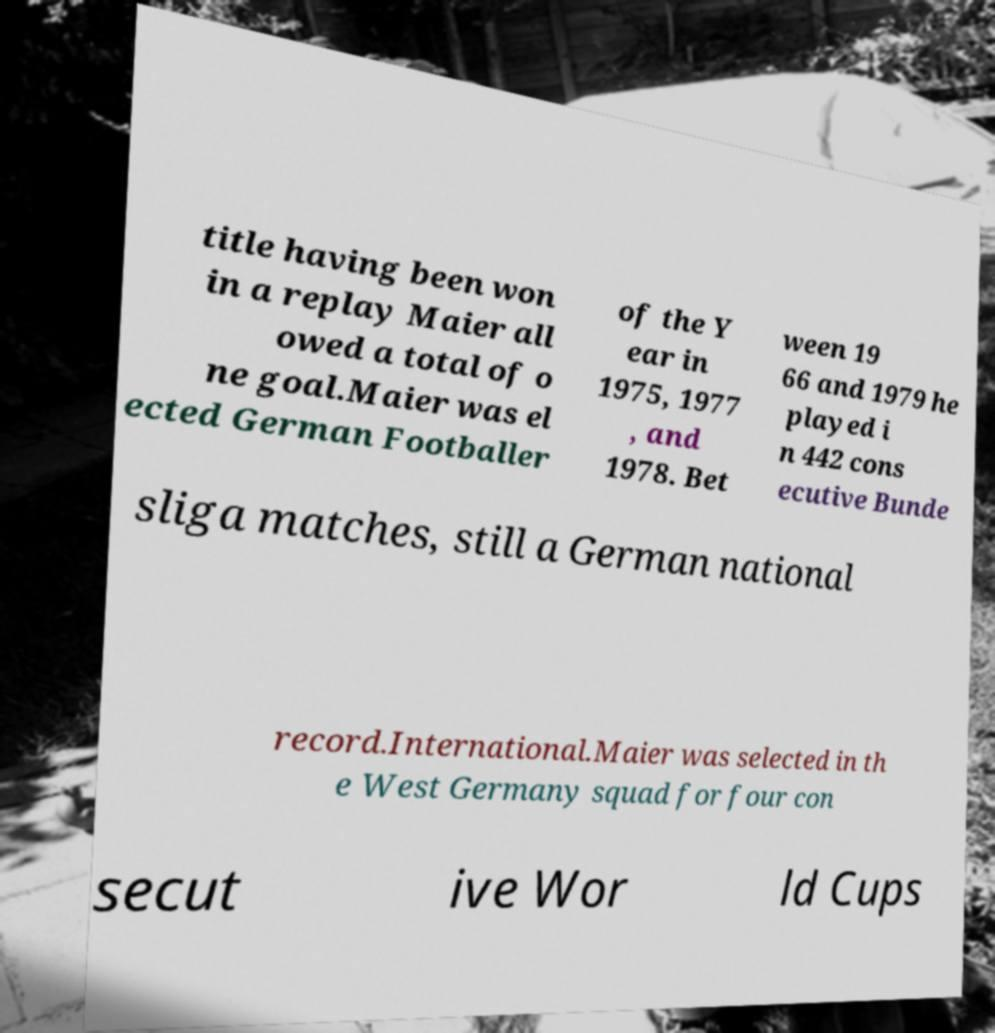Can you accurately transcribe the text from the provided image for me? title having been won in a replay Maier all owed a total of o ne goal.Maier was el ected German Footballer of the Y ear in 1975, 1977 , and 1978. Bet ween 19 66 and 1979 he played i n 442 cons ecutive Bunde sliga matches, still a German national record.International.Maier was selected in th e West Germany squad for four con secut ive Wor ld Cups 